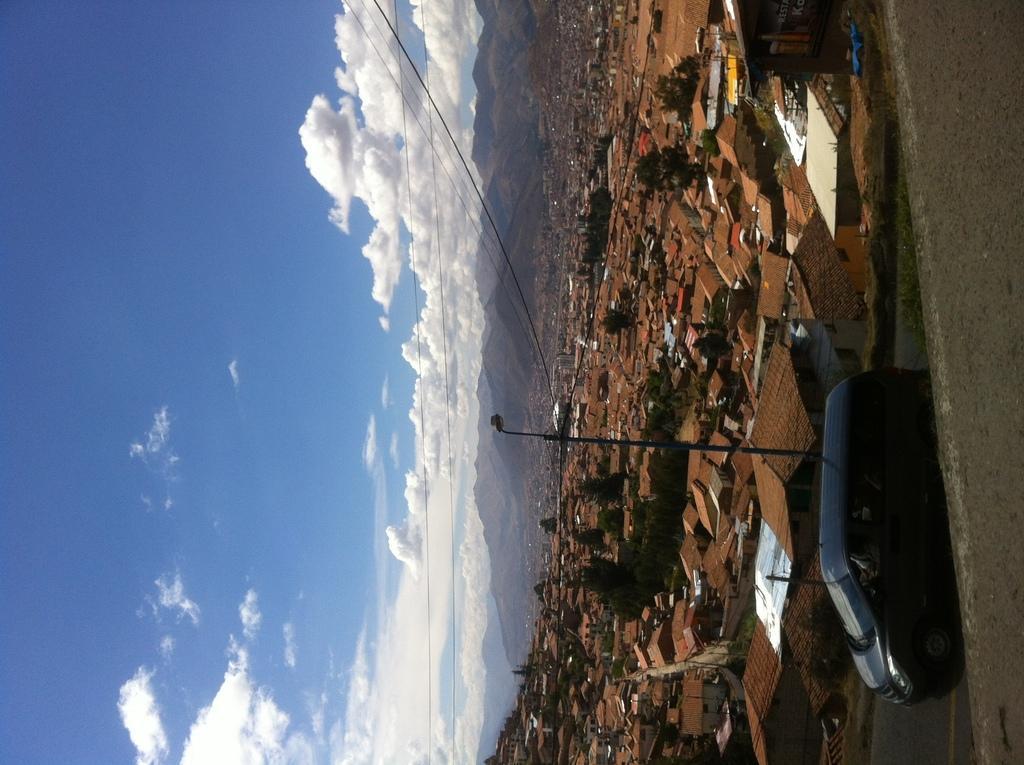In one or two sentences, can you explain what this image depicts? In this image we can see some houses, poles, trees and other objects. On the right side of the image there is the road and a vehicle. In the background of the image there are mountains. On the left side of the image there is the sky and cables. 